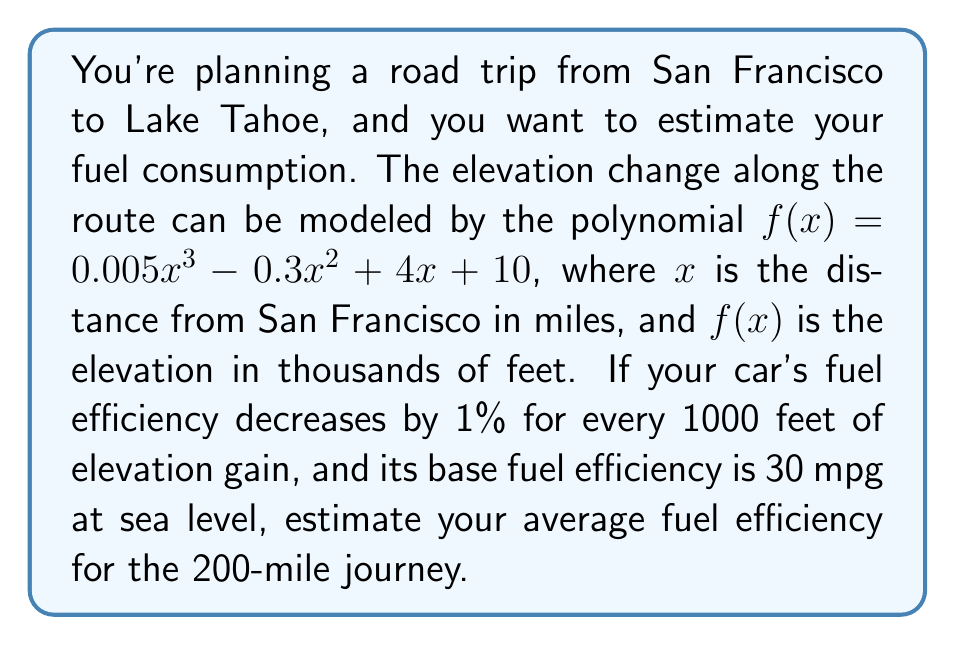Solve this math problem. 1. First, we need to find the total elevation gain:
   - Elevation at start (San Francisco, x = 0): $f(0) = 10$ thousand feet
   - Elevation at end (Lake Tahoe, x = 200): 
     $f(200) = 0.005(200)^3 - 0.3(200)^2 + 4(200) + 10 = 40$ thousand feet
   - Total elevation gain: $40 - 10 = 30$ thousand feet

2. Calculate the effect on fuel efficiency:
   - Efficiency decrease: $30 \times 1\% = 30\%$
   - Remaining efficiency: $100\% - 30\% = 70\%$

3. Apply the efficiency decrease to the base fuel efficiency:
   - New efficiency: $30 \text{ mpg} \times 70\% = 21 \text{ mpg}$

Therefore, the estimated average fuel efficiency for the journey is 21 mpg.
Answer: 21 mpg 